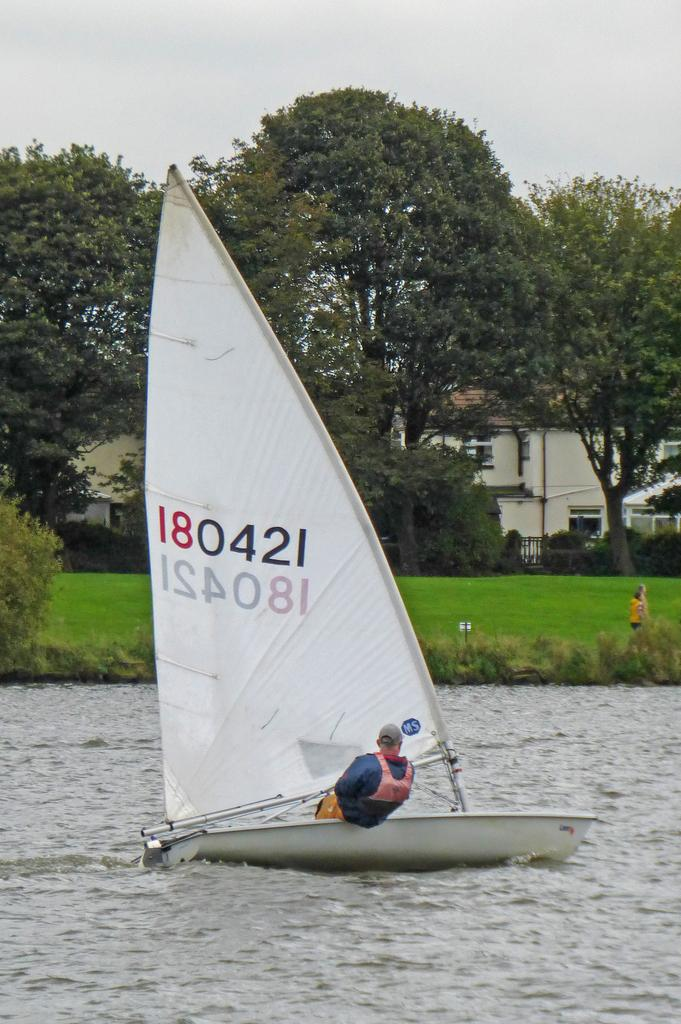What is the person in the image doing? The person is sitting on a boat. How is the boat positioned in the image? The boat is above the water. What can be seen in the background of the image? There is grass, plants, a person, trees, a house, and the sky visible in the background. What type of brick is being used to build the library in the image? There is no library present in the image, so it is not possible to determine the type of brick being used. 